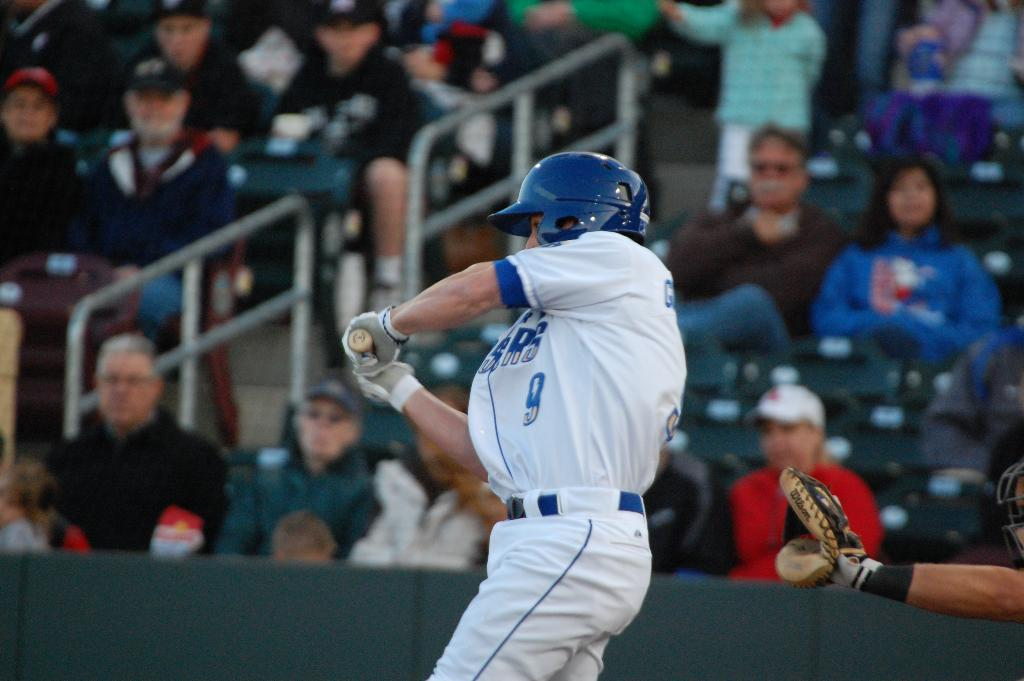Provide a one-sentence caption for the provided image. Spectators watch as player number 9 swings the baseball bat in his blue and white uniform. 